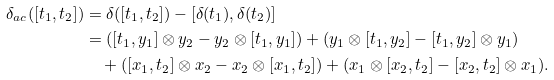<formula> <loc_0><loc_0><loc_500><loc_500>\delta _ { a c } ( [ t _ { 1 } , t _ { 2 } ] ) & = \delta ( [ t _ { 1 } , t _ { 2 } ] ) - [ \delta ( t _ { 1 } ) , \delta ( t _ { 2 } ) ] \\ & = ( [ t _ { 1 } , y _ { 1 } ] \otimes y _ { 2 } - y _ { 2 } \otimes [ t _ { 1 } , y _ { 1 } ] ) + ( y _ { 1 } \otimes [ t _ { 1 } , y _ { 2 } ] - [ t _ { 1 } , y _ { 2 } ] \otimes y _ { 1 } ) \\ & \quad + ( [ x _ { 1 } , t _ { 2 } ] \otimes x _ { 2 } - x _ { 2 } \otimes [ x _ { 1 } , t _ { 2 } ] ) + ( x _ { 1 } \otimes [ x _ { 2 } , t _ { 2 } ] - [ x _ { 2 } , t _ { 2 } ] \otimes x _ { 1 } ) .</formula> 